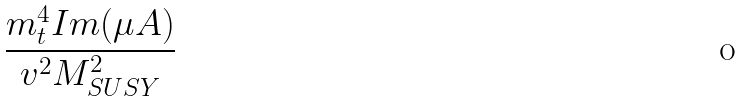Convert formula to latex. <formula><loc_0><loc_0><loc_500><loc_500>\frac { m ^ { 4 } _ { t } I m ( \mu A ) } { v ^ { 2 } M ^ { 2 } _ { S U S Y } }</formula> 